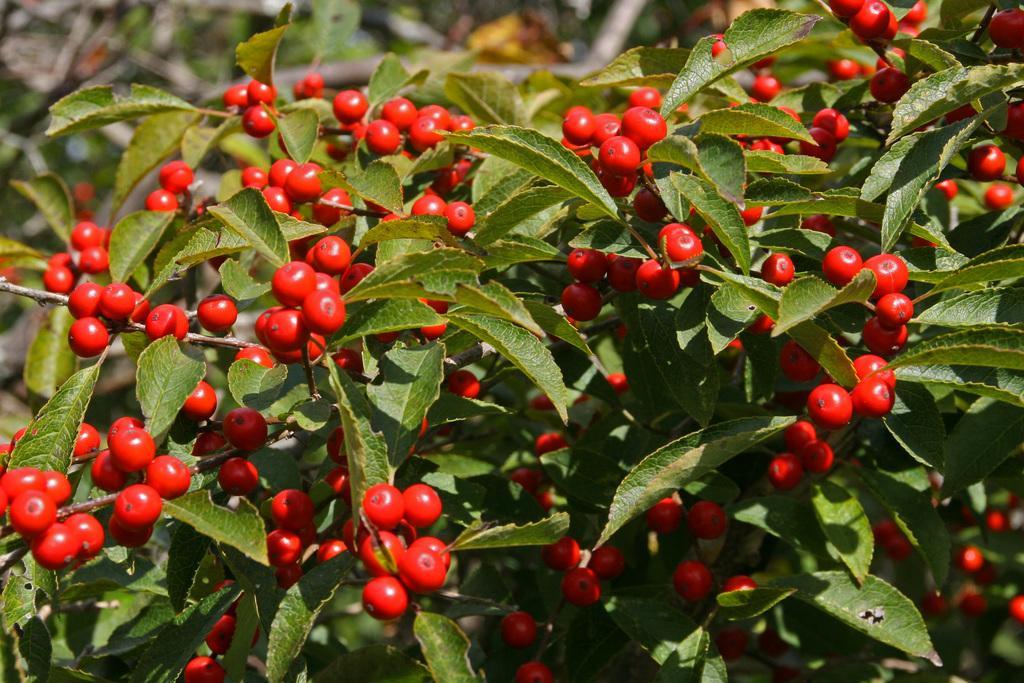Describe this image in one or two sentences. In this picture we can see a few red color fruits, green leaves and stems. Background is blurry. 